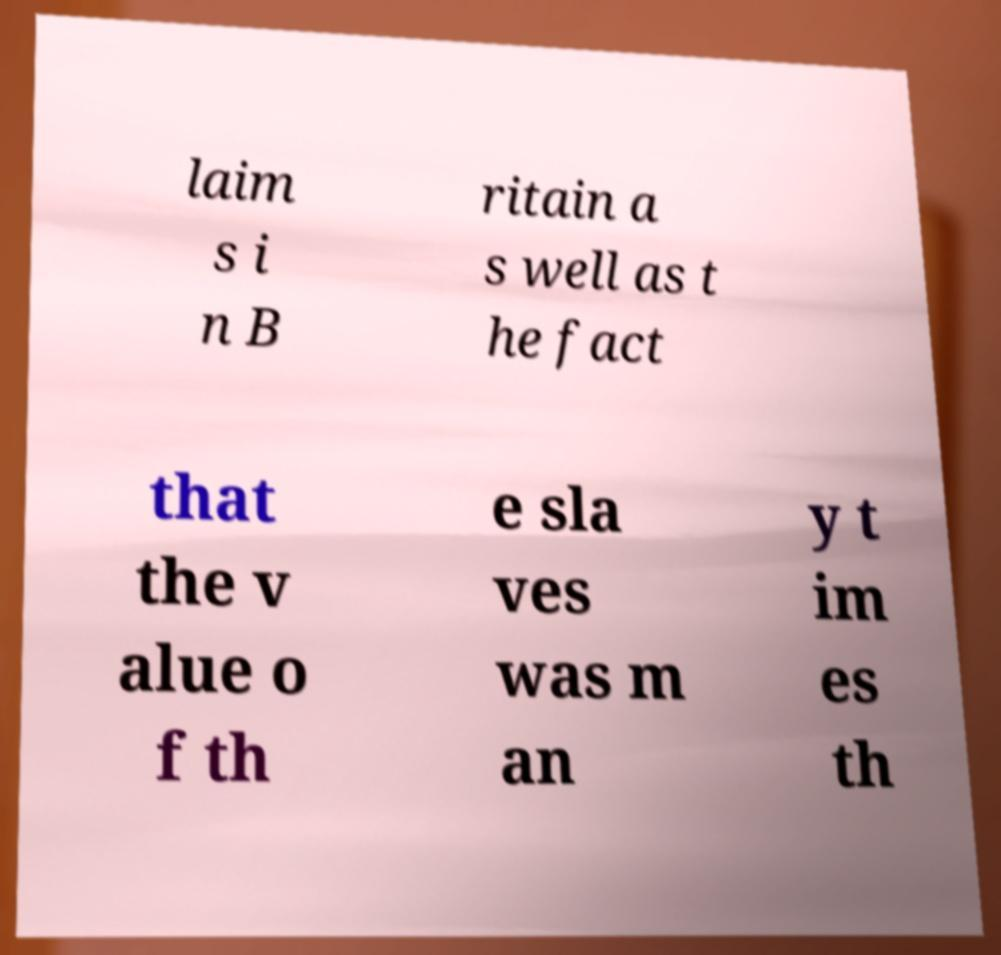Could you extract and type out the text from this image? laim s i n B ritain a s well as t he fact that the v alue o f th e sla ves was m an y t im es th 